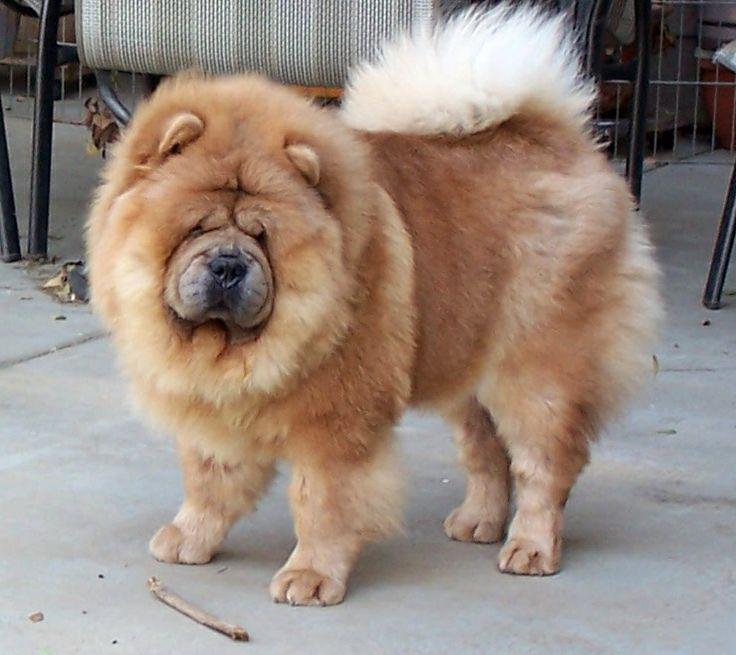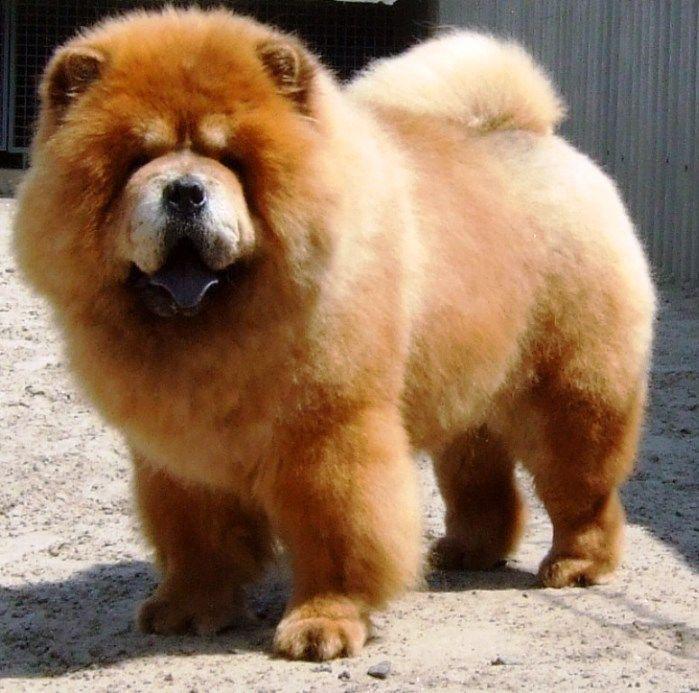The first image is the image on the left, the second image is the image on the right. Given the left and right images, does the statement "The dog in the image on the right has its mouth open" hold true? Answer yes or no. Yes. 